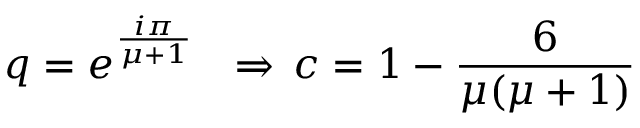<formula> <loc_0><loc_0><loc_500><loc_500>q = e ^ { \frac { i \pi } { \mu + 1 } } \quad R i g h t a r r o w \, c = 1 - \frac { 6 } { \mu ( \mu + 1 ) }</formula> 